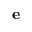<formula> <loc_0><loc_0><loc_500><loc_500>{ \mathbf e }</formula> 